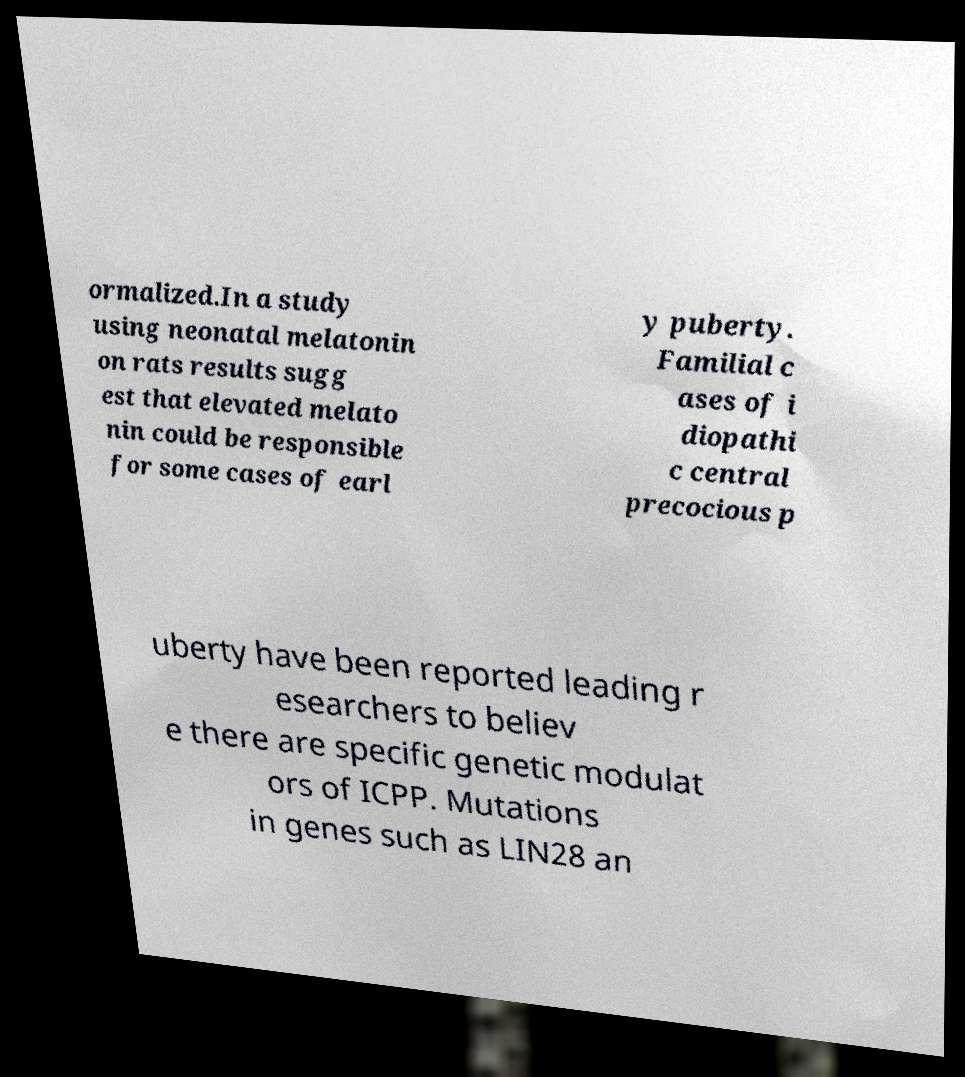Please identify and transcribe the text found in this image. ormalized.In a study using neonatal melatonin on rats results sugg est that elevated melato nin could be responsible for some cases of earl y puberty. Familial c ases of i diopathi c central precocious p uberty have been reported leading r esearchers to believ e there are specific genetic modulat ors of ICPP. Mutations in genes such as LIN28 an 